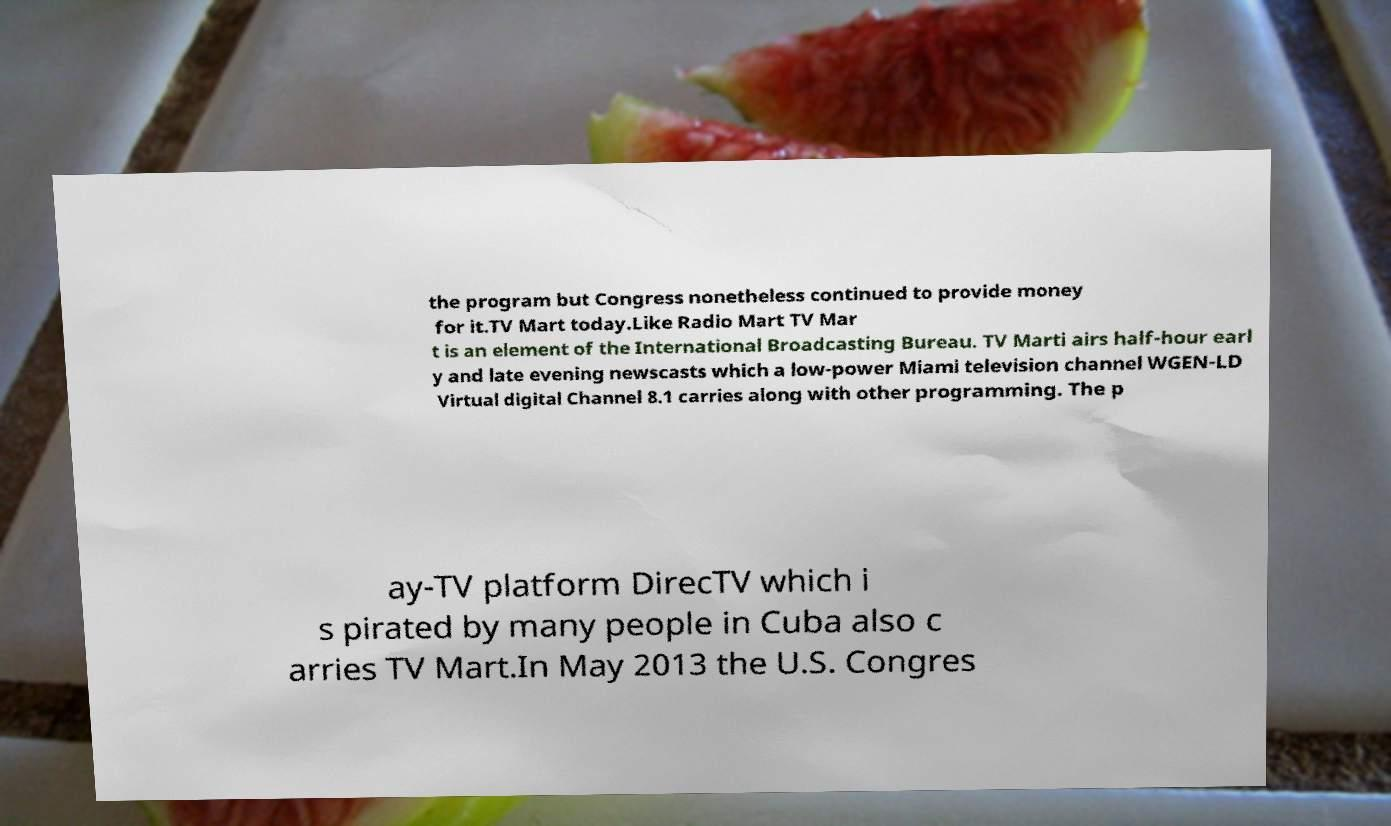Can you read and provide the text displayed in the image?This photo seems to have some interesting text. Can you extract and type it out for me? the program but Congress nonetheless continued to provide money for it.TV Mart today.Like Radio Mart TV Mar t is an element of the International Broadcasting Bureau. TV Marti airs half-hour earl y and late evening newscasts which a low-power Miami television channel WGEN-LD Virtual digital Channel 8.1 carries along with other programming. The p ay-TV platform DirecTV which i s pirated by many people in Cuba also c arries TV Mart.In May 2013 the U.S. Congres 